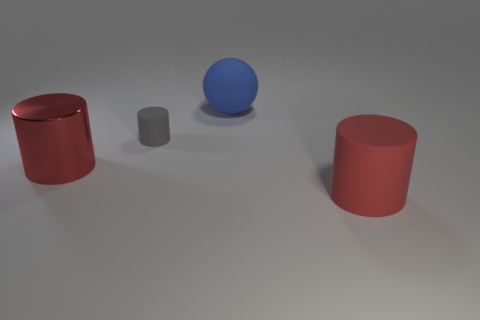The large matte object that is the same color as the big metal cylinder is what shape?
Provide a succinct answer. Cylinder. What size is the object that is the same color as the large shiny cylinder?
Give a very brief answer. Large. How many objects have the same color as the big metal cylinder?
Ensure brevity in your answer.  1. Do the metallic object and the large blue thing have the same shape?
Your answer should be very brief. No. There is a matte cylinder that is on the left side of the big matte cylinder; what size is it?
Provide a succinct answer. Small. What size is the blue object that is the same material as the small gray thing?
Your answer should be very brief. Large. Are there fewer matte spheres than cyan objects?
Your answer should be compact. No. What is the material of the cylinder that is the same size as the red matte thing?
Offer a terse response. Metal. Is the number of big green blocks greater than the number of metal things?
Offer a terse response. No. How many other objects are there of the same color as the big rubber cylinder?
Ensure brevity in your answer.  1. 